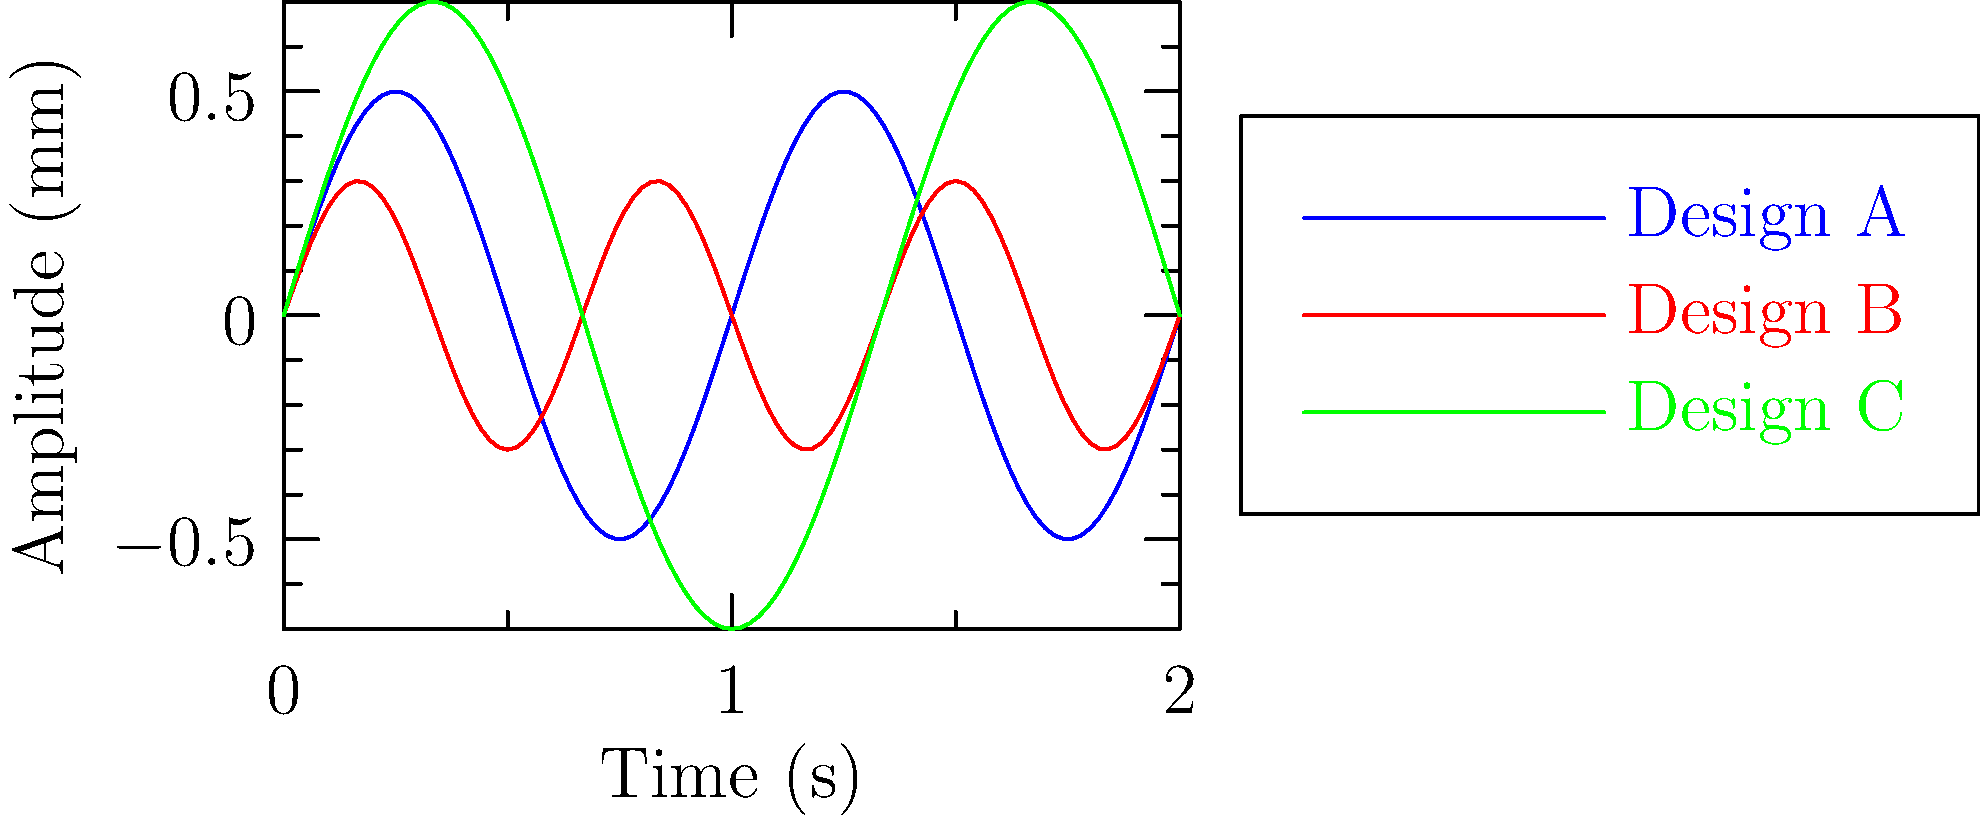A competitor has developed three new drone propeller blade designs (A, B, and C) and conducted vibration analysis tests. The graph shows the vibration patterns of each design over time. Which design is likely to have the best overall performance in terms of stability and efficiency for high-precision aerial photography drones? To determine the best design for high-precision aerial photography drones, we need to analyze the vibration patterns:

1. Amplitude: Lower amplitudes generally indicate less vibration.
   Design A: Max amplitude ≈ 0.5 mm
   Design B: Max amplitude ≈ 0.3 mm
   Design C: Max amplitude ≈ 0.7 mm

2. Frequency: Higher frequencies can be more easily dampened but may cause more wear.
   Design A: Medium frequency (2 cycles in 2 seconds)
   Design B: Highest frequency (3 cycles in 2 seconds)
   Design C: Lowest frequency (1.5 cycles in 2 seconds)

3. Stability: Consistent, predictable patterns are easier to compensate for.
   All designs show consistent sinusoidal patterns.

4. For high-precision aerial photography:
   - Lower amplitude is crucial to minimize camera shake.
   - Consistent patterns are beneficial for vibration compensation algorithms.
   - Moderate to high frequencies are preferable as they're easier to dampen.

5. Ranking the designs:
   Design B: Lowest amplitude, highest frequency, consistent pattern.
   Design A: Medium amplitude and frequency, consistent pattern.
   Design C: Highest amplitude, lowest frequency, consistent pattern.

Therefore, Design B is likely to have the best overall performance for high-precision aerial photography drones due to its low amplitude and easily dampenable high frequency.
Answer: Design B 